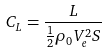Convert formula to latex. <formula><loc_0><loc_0><loc_500><loc_500>C _ { L } = \frac { L } { \frac { 1 } { 2 } \rho _ { 0 } V _ { e } ^ { 2 } S }</formula> 